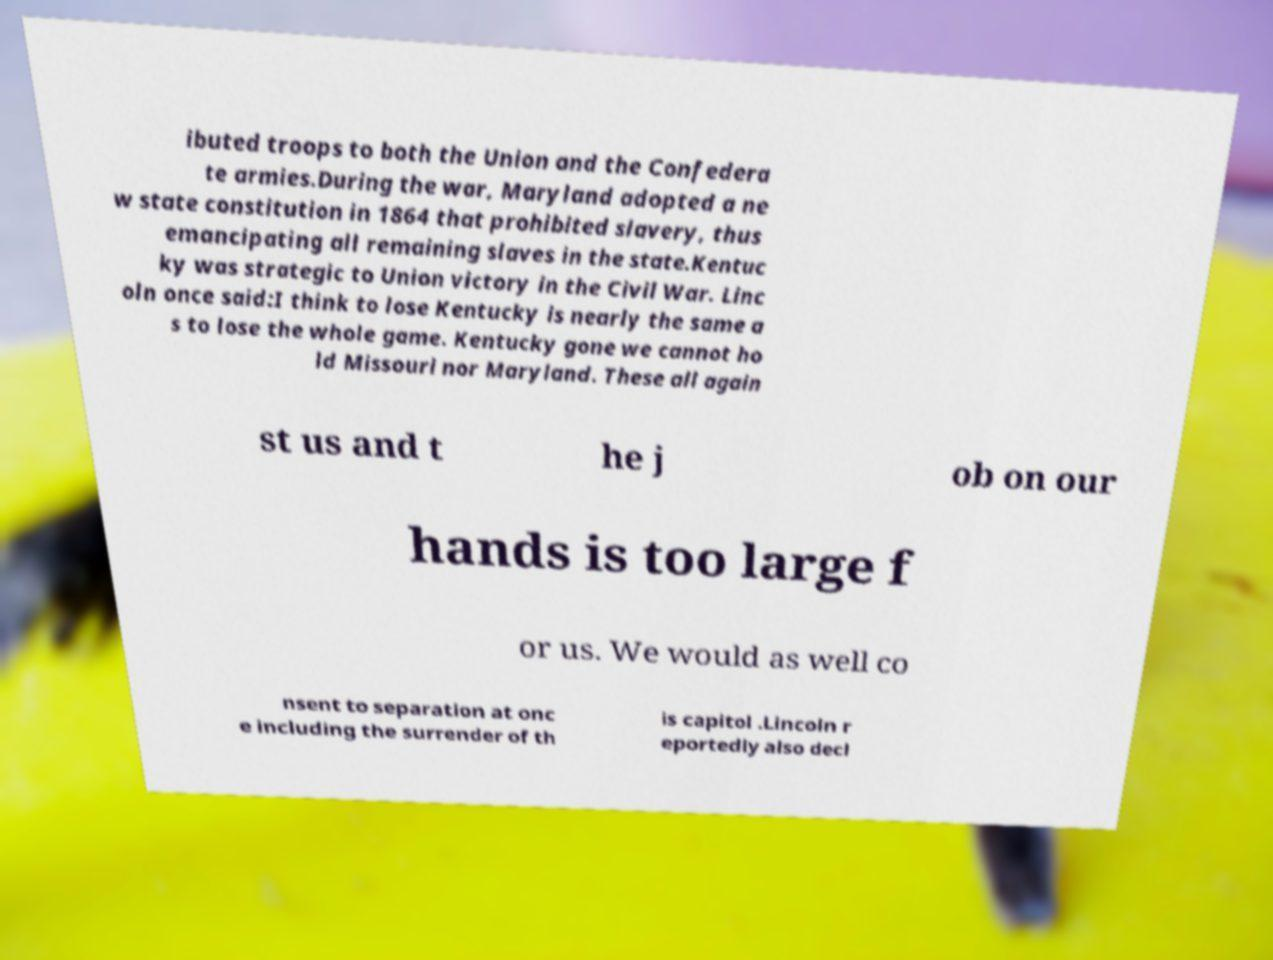Could you assist in decoding the text presented in this image and type it out clearly? ibuted troops to both the Union and the Confedera te armies.During the war, Maryland adopted a ne w state constitution in 1864 that prohibited slavery, thus emancipating all remaining slaves in the state.Kentuc ky was strategic to Union victory in the Civil War. Linc oln once said:I think to lose Kentucky is nearly the same a s to lose the whole game. Kentucky gone we cannot ho ld Missouri nor Maryland. These all again st us and t he j ob on our hands is too large f or us. We would as well co nsent to separation at onc e including the surrender of th is capitol .Lincoln r eportedly also decl 